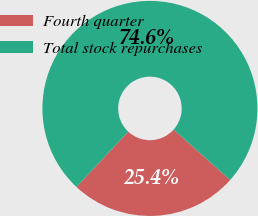Convert chart. <chart><loc_0><loc_0><loc_500><loc_500><pie_chart><fcel>Fourth quarter<fcel>Total stock repurchases<nl><fcel>25.38%<fcel>74.62%<nl></chart> 